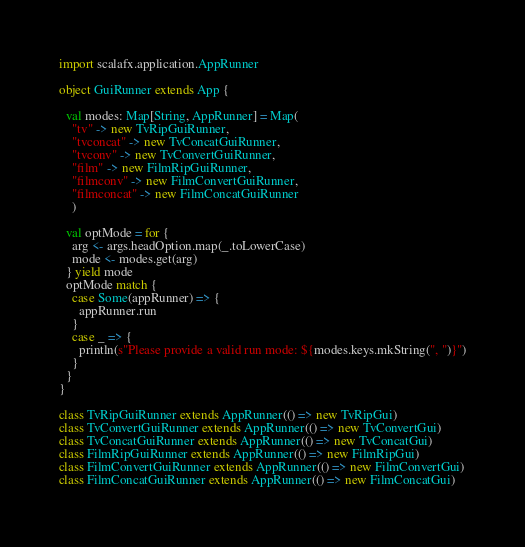Convert code to text. <code><loc_0><loc_0><loc_500><loc_500><_Scala_>
import scalafx.application.AppRunner

object GuiRunner extends App {

  val modes: Map[String, AppRunner] = Map(
    "tv" -> new TvRipGuiRunner,
    "tvconcat" -> new TvConcatGuiRunner,
    "tvconv" -> new TvConvertGuiRunner,
    "film" -> new FilmRipGuiRunner,
    "filmconv" -> new FilmConvertGuiRunner,
    "filmconcat" -> new FilmConcatGuiRunner
    )

  val optMode = for {
    arg <- args.headOption.map(_.toLowerCase)
    mode <- modes.get(arg)
  } yield mode
  optMode match {
    case Some(appRunner) => {
      appRunner.run
    }
    case _ => {
      println(s"Please provide a valid run mode: ${modes.keys.mkString(", ")}")
    }
  }
}

class TvRipGuiRunner extends AppRunner(() => new TvRipGui)
class TvConvertGuiRunner extends AppRunner(() => new TvConvertGui)
class TvConcatGuiRunner extends AppRunner(() => new TvConcatGui)
class FilmRipGuiRunner extends AppRunner(() => new FilmRipGui)
class FilmConvertGuiRunner extends AppRunner(() => new FilmConvertGui)
class FilmConcatGuiRunner extends AppRunner(() => new FilmConcatGui)
</code> 